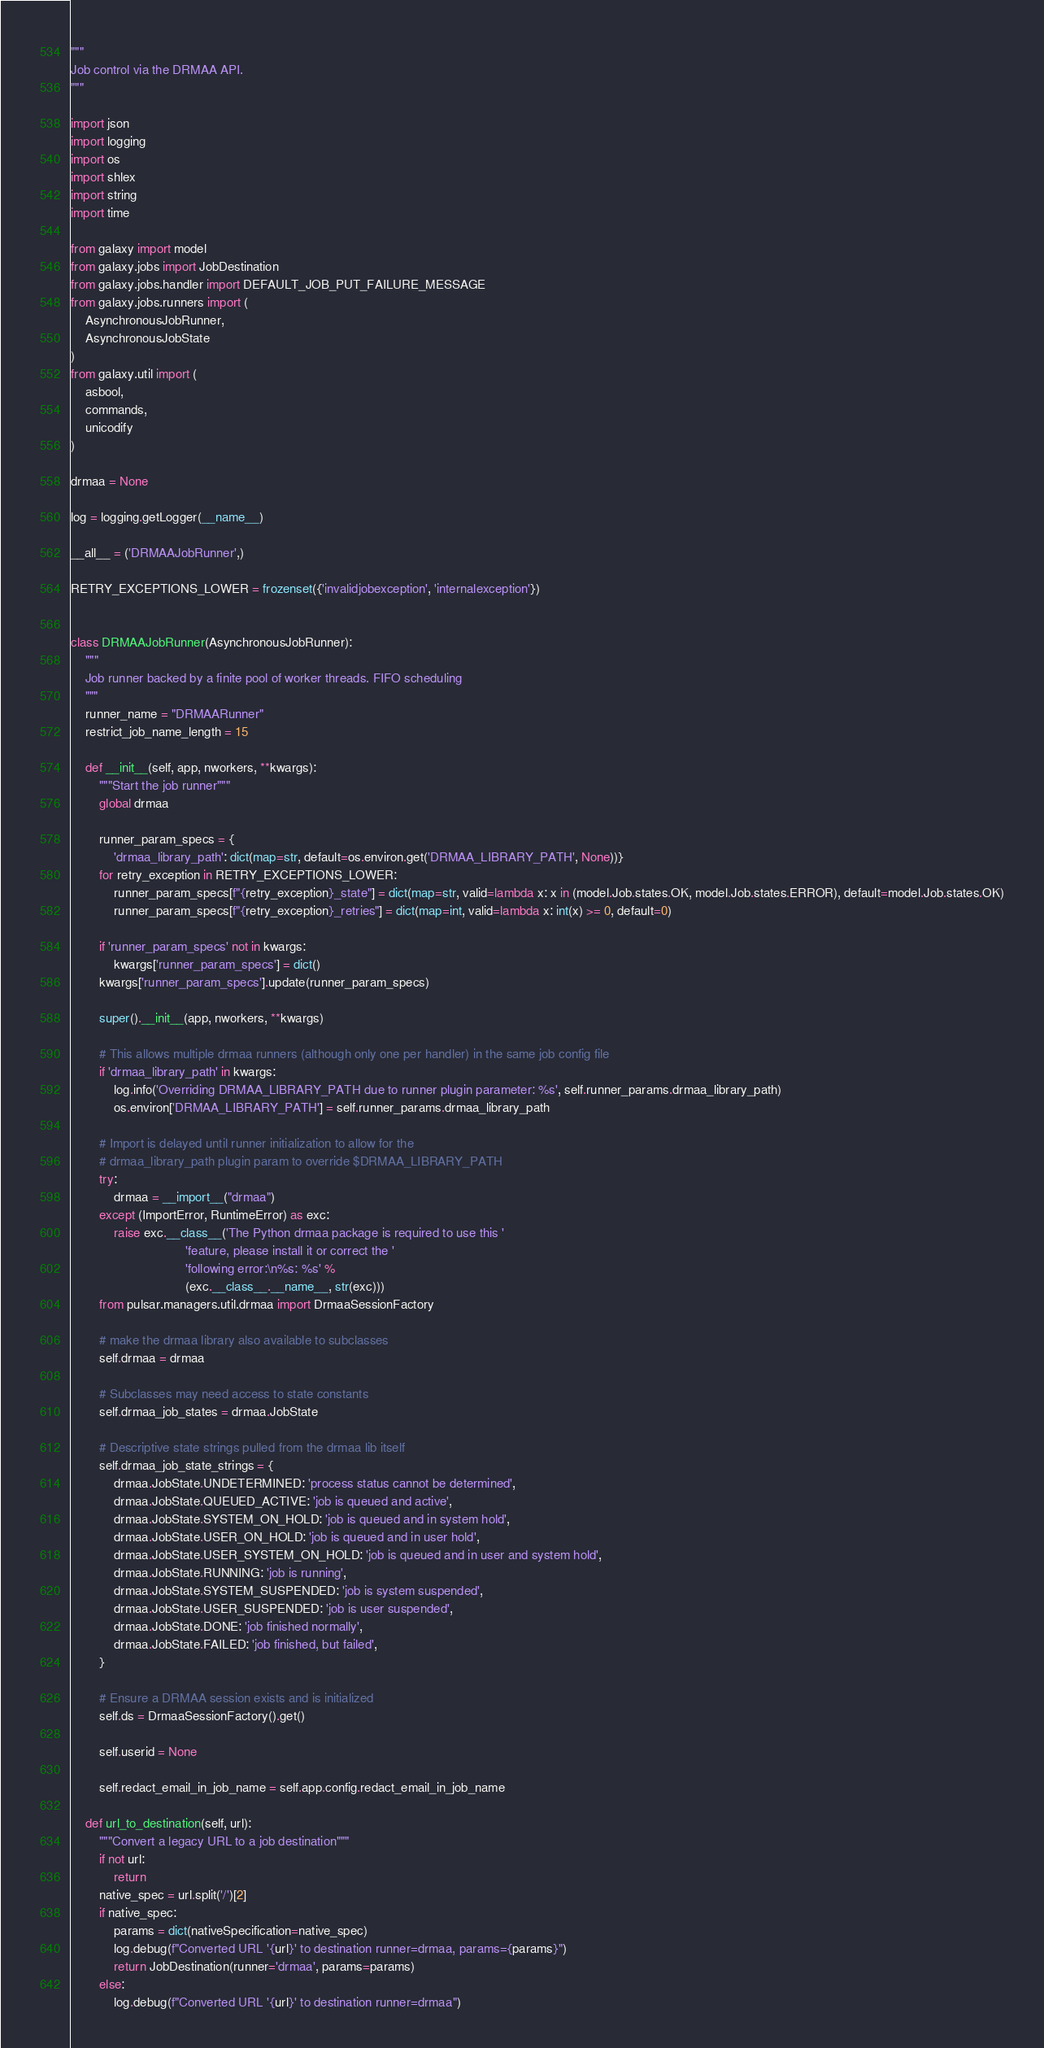Convert code to text. <code><loc_0><loc_0><loc_500><loc_500><_Python_>"""
Job control via the DRMAA API.
"""

import json
import logging
import os
import shlex
import string
import time

from galaxy import model
from galaxy.jobs import JobDestination
from galaxy.jobs.handler import DEFAULT_JOB_PUT_FAILURE_MESSAGE
from galaxy.jobs.runners import (
    AsynchronousJobRunner,
    AsynchronousJobState
)
from galaxy.util import (
    asbool,
    commands,
    unicodify
)

drmaa = None

log = logging.getLogger(__name__)

__all__ = ('DRMAAJobRunner',)

RETRY_EXCEPTIONS_LOWER = frozenset({'invalidjobexception', 'internalexception'})


class DRMAAJobRunner(AsynchronousJobRunner):
    """
    Job runner backed by a finite pool of worker threads. FIFO scheduling
    """
    runner_name = "DRMAARunner"
    restrict_job_name_length = 15

    def __init__(self, app, nworkers, **kwargs):
        """Start the job runner"""
        global drmaa

        runner_param_specs = {
            'drmaa_library_path': dict(map=str, default=os.environ.get('DRMAA_LIBRARY_PATH', None))}
        for retry_exception in RETRY_EXCEPTIONS_LOWER:
            runner_param_specs[f"{retry_exception}_state"] = dict(map=str, valid=lambda x: x in (model.Job.states.OK, model.Job.states.ERROR), default=model.Job.states.OK)
            runner_param_specs[f"{retry_exception}_retries"] = dict(map=int, valid=lambda x: int(x) >= 0, default=0)

        if 'runner_param_specs' not in kwargs:
            kwargs['runner_param_specs'] = dict()
        kwargs['runner_param_specs'].update(runner_param_specs)

        super().__init__(app, nworkers, **kwargs)

        # This allows multiple drmaa runners (although only one per handler) in the same job config file
        if 'drmaa_library_path' in kwargs:
            log.info('Overriding DRMAA_LIBRARY_PATH due to runner plugin parameter: %s', self.runner_params.drmaa_library_path)
            os.environ['DRMAA_LIBRARY_PATH'] = self.runner_params.drmaa_library_path

        # Import is delayed until runner initialization to allow for the
        # drmaa_library_path plugin param to override $DRMAA_LIBRARY_PATH
        try:
            drmaa = __import__("drmaa")
        except (ImportError, RuntimeError) as exc:
            raise exc.__class__('The Python drmaa package is required to use this '
                                'feature, please install it or correct the '
                                'following error:\n%s: %s' %
                                (exc.__class__.__name__, str(exc)))
        from pulsar.managers.util.drmaa import DrmaaSessionFactory

        # make the drmaa library also available to subclasses
        self.drmaa = drmaa

        # Subclasses may need access to state constants
        self.drmaa_job_states = drmaa.JobState

        # Descriptive state strings pulled from the drmaa lib itself
        self.drmaa_job_state_strings = {
            drmaa.JobState.UNDETERMINED: 'process status cannot be determined',
            drmaa.JobState.QUEUED_ACTIVE: 'job is queued and active',
            drmaa.JobState.SYSTEM_ON_HOLD: 'job is queued and in system hold',
            drmaa.JobState.USER_ON_HOLD: 'job is queued and in user hold',
            drmaa.JobState.USER_SYSTEM_ON_HOLD: 'job is queued and in user and system hold',
            drmaa.JobState.RUNNING: 'job is running',
            drmaa.JobState.SYSTEM_SUSPENDED: 'job is system suspended',
            drmaa.JobState.USER_SUSPENDED: 'job is user suspended',
            drmaa.JobState.DONE: 'job finished normally',
            drmaa.JobState.FAILED: 'job finished, but failed',
        }

        # Ensure a DRMAA session exists and is initialized
        self.ds = DrmaaSessionFactory().get()

        self.userid = None

        self.redact_email_in_job_name = self.app.config.redact_email_in_job_name

    def url_to_destination(self, url):
        """Convert a legacy URL to a job destination"""
        if not url:
            return
        native_spec = url.split('/')[2]
        if native_spec:
            params = dict(nativeSpecification=native_spec)
            log.debug(f"Converted URL '{url}' to destination runner=drmaa, params={params}")
            return JobDestination(runner='drmaa', params=params)
        else:
            log.debug(f"Converted URL '{url}' to destination runner=drmaa")</code> 